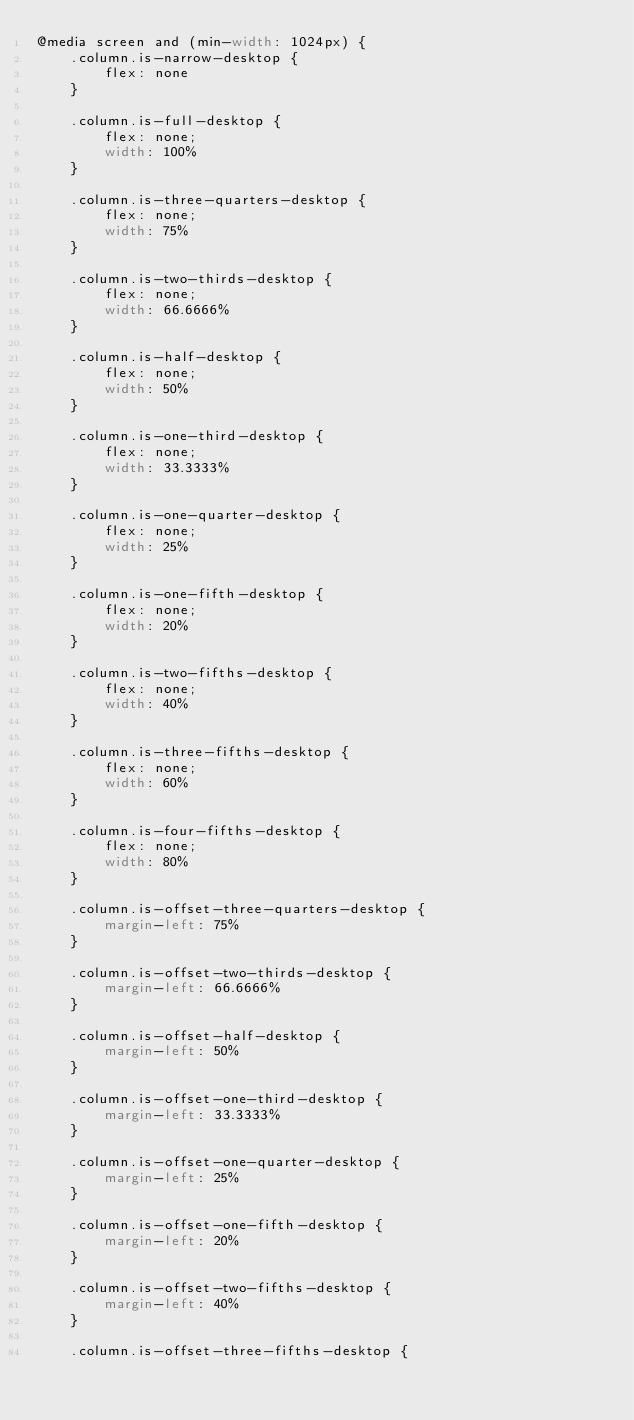<code> <loc_0><loc_0><loc_500><loc_500><_CSS_>@media screen and (min-width: 1024px) {
    .column.is-narrow-desktop {
        flex: none
    }

    .column.is-full-desktop {
        flex: none;
        width: 100%
    }

    .column.is-three-quarters-desktop {
        flex: none;
        width: 75%
    }

    .column.is-two-thirds-desktop {
        flex: none;
        width: 66.6666%
    }

    .column.is-half-desktop {
        flex: none;
        width: 50%
    }

    .column.is-one-third-desktop {
        flex: none;
        width: 33.3333%
    }

    .column.is-one-quarter-desktop {
        flex: none;
        width: 25%
    }

    .column.is-one-fifth-desktop {
        flex: none;
        width: 20%
    }

    .column.is-two-fifths-desktop {
        flex: none;
        width: 40%
    }

    .column.is-three-fifths-desktop {
        flex: none;
        width: 60%
    }

    .column.is-four-fifths-desktop {
        flex: none;
        width: 80%
    }

    .column.is-offset-three-quarters-desktop {
        margin-left: 75%
    }

    .column.is-offset-two-thirds-desktop {
        margin-left: 66.6666%
    }

    .column.is-offset-half-desktop {
        margin-left: 50%
    }

    .column.is-offset-one-third-desktop {
        margin-left: 33.3333%
    }

    .column.is-offset-one-quarter-desktop {
        margin-left: 25%
    }

    .column.is-offset-one-fifth-desktop {
        margin-left: 20%
    }

    .column.is-offset-two-fifths-desktop {
        margin-left: 40%
    }

    .column.is-offset-three-fifths-desktop {</code> 